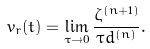Convert formula to latex. <formula><loc_0><loc_0><loc_500><loc_500>v _ { r } ( t ) = \lim _ { \tau \rightarrow 0 } \frac { \zeta ^ { ( n + 1 ) } } { \tau d ^ { ( n ) } } .</formula> 